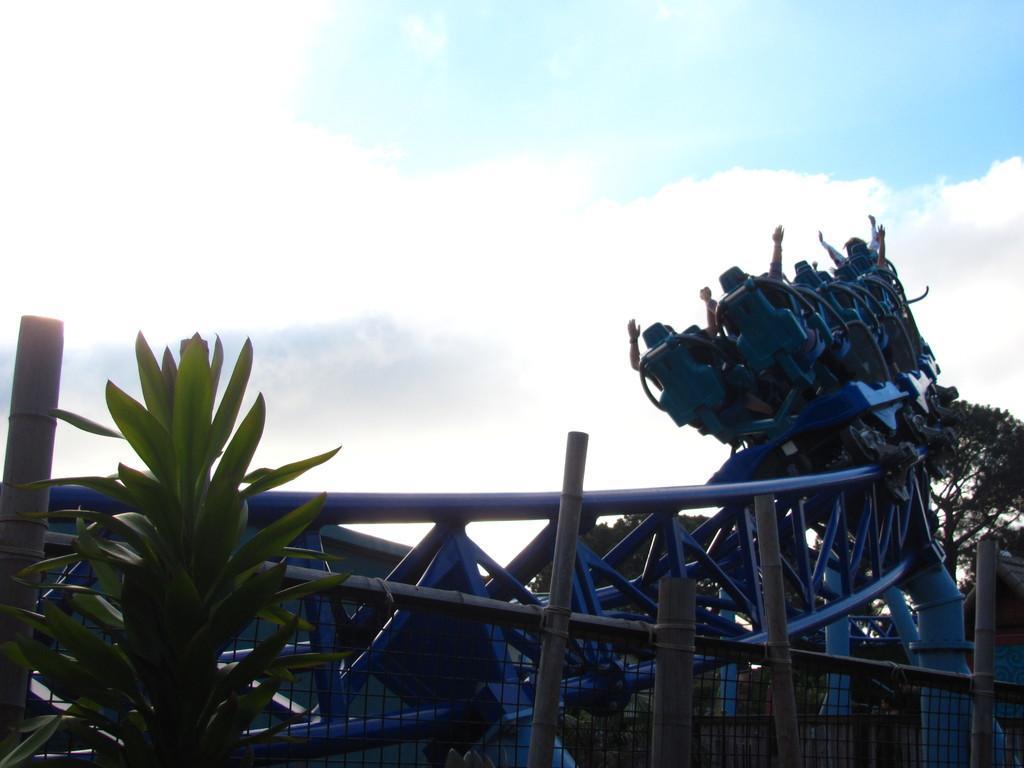Please provide a concise description of this image. In the picture I can see fence, plants, trees, people sitting on a roller coaster and some other objects. In the background I can see the sky. 